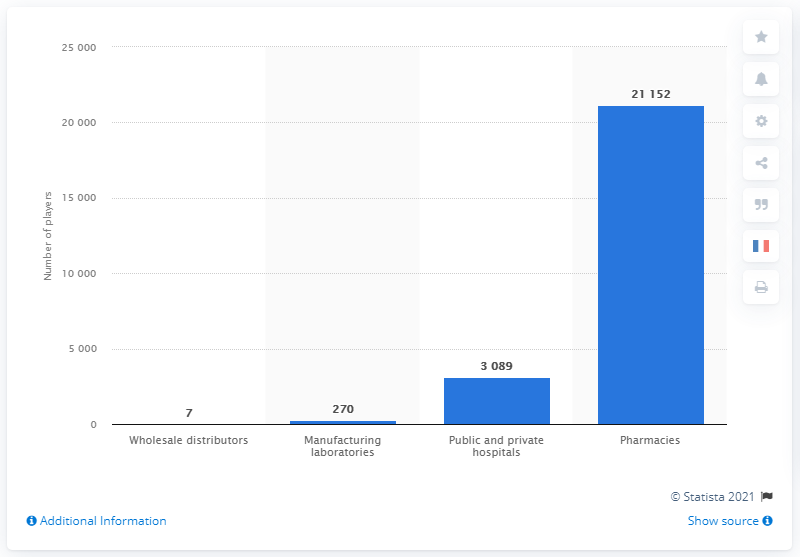Indicate a few pertinent items in this graphic. According to the information available in 2018, there were 270 manufacturing laboratories in France. 